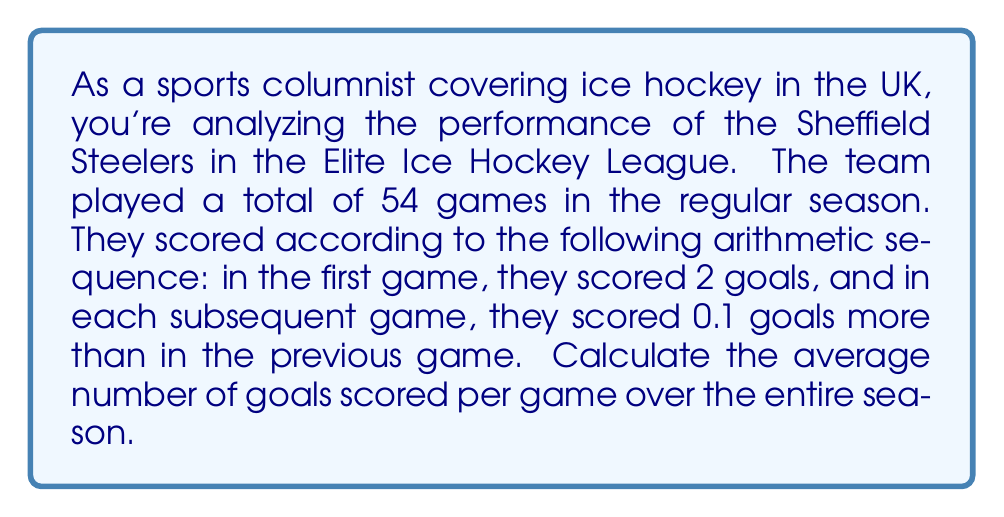Show me your answer to this math problem. Let's approach this step-by-step:

1) We're dealing with an arithmetic sequence where:
   - First term, $a_1 = 2$
   - Common difference, $d = 0.1$
   - Number of terms, $n = 54$

2) To find the average, we need to find the total number of goals and divide by the number of games.

3) For an arithmetic sequence, the sum of terms is given by:

   $S_n = \frac{n}{2}(a_1 + a_n)$

   where $a_n$ is the last term.

4) We can find $a_n$ using the arithmetic sequence formula:

   $a_n = a_1 + (n-1)d$
   $a_{54} = 2 + (54-1)(0.1) = 2 + 5.3 = 7.3$

5) Now we can calculate the sum:

   $S_{54} = \frac{54}{2}(2 + 7.3) = 27(9.3) = 251.1$

6) The average is the sum divided by the number of games:

   $\text{Average} = \frac{251.1}{54} = 4.65$
Answer: The average number of goals scored per game over the entire season is $4.65$ goals. 